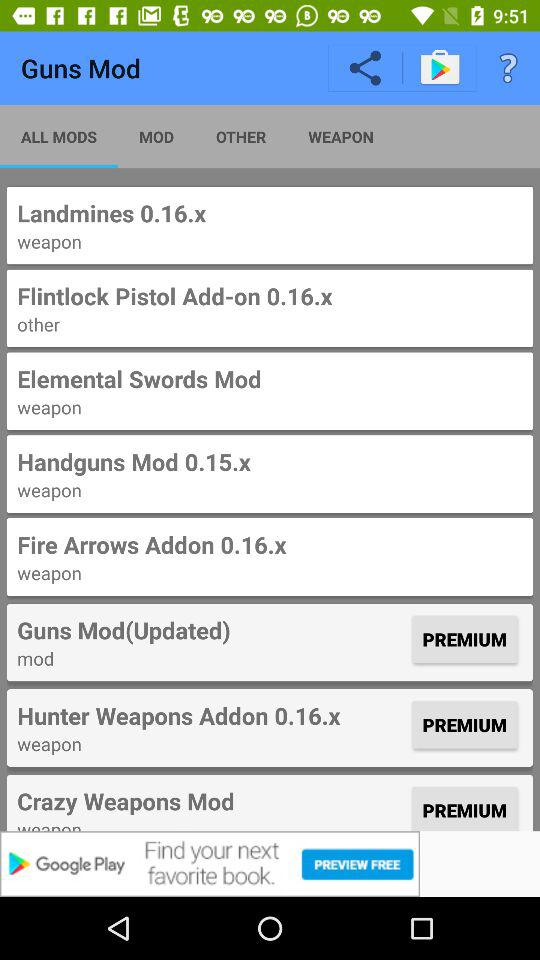Which tab is selected? The selected tab is "ALL MODS". 